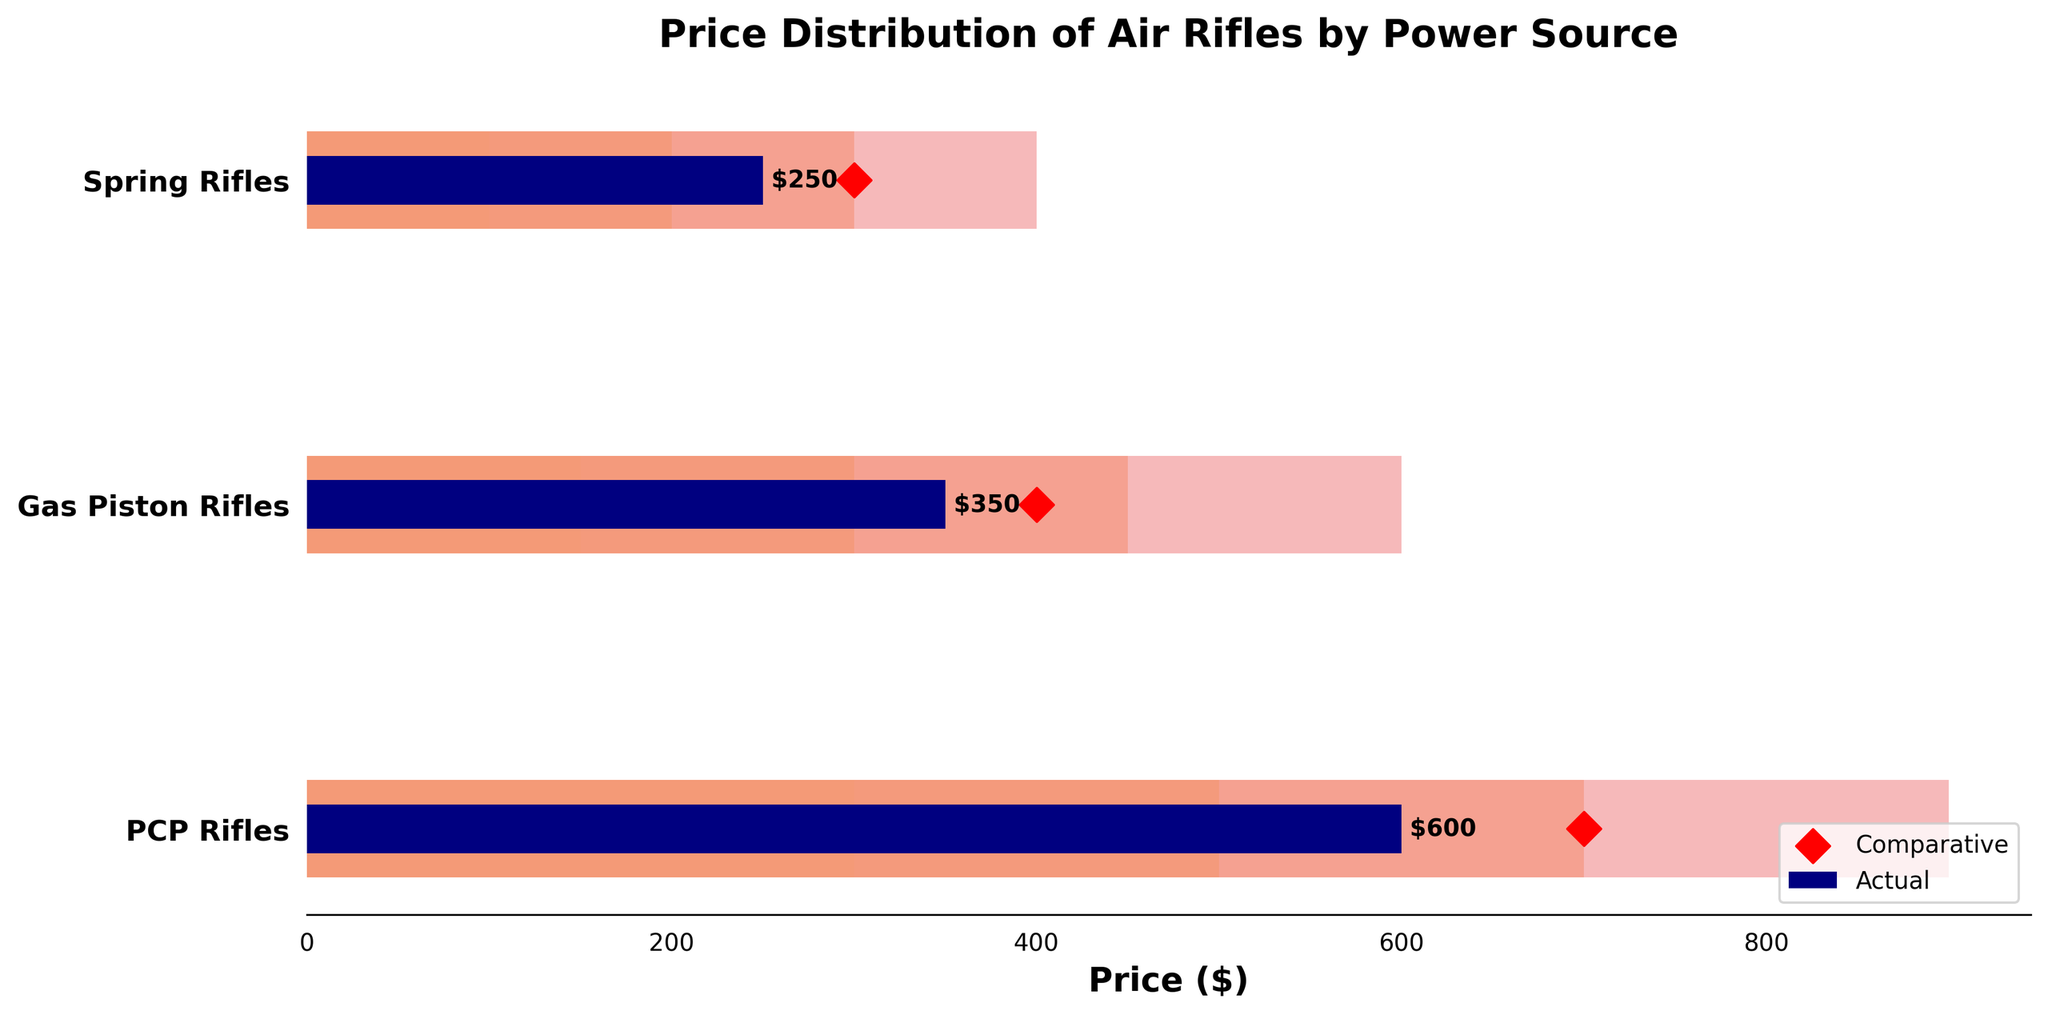What is the title of the chart? The title is located at the top of the figure, typically in larger and bolder text than other elements. It provides a summary of what the chart represents.
Answer: Price Distribution of Air Rifles by Power Source Which power source has the highest actual price? From the chart, you observe the lengths of the navy bars representing actual prices. The PCP Rifles' bar is the longest among the three categories.
Answer: PCP Rifles What is the comparative price for Spring Rifles? Look for the red diamond marker on the horizontal line corresponding to Spring Rifles. The value associated with it is the comparative price.
Answer: 300 How many price ranges are shown in the chart for each category? Each category has 4 shaded regions representing price ranges. This can be counted on the figure directly.
Answer: 4 Which category has its actual price closest to the upper limit of its third range? Compare the actual price bars for each category to their respective third range boundaries. The PCP Rifles' actual price of 600 is equal to its third range upper limit of 700.
Answer: PCP Rifles What is the range of prices for Gas Piston Rifles? Read the four value boundaries from the chart for Gas Piston Rifles, which are 150, 300, 450, and 600. The lowest and highest values give the total range of prices.
Answer: 150-600 Which category's actual price is below the first range boundary? Compare the actual price bars to the first range boundaries for each category. No actual price bars fall below the first range boundary in any category.
Answer: None What is the difference between the comparative prices of PCP Rifles and Gas Piston Rifles? Subtract the comparative price of Gas Piston Rifles from that of PCP Rifles: 700 - 400. This provides the difference in prices.
Answer: 300 Is the actual price of Gas Piston Rifles within its second price range? Compare the actual price of Gas Piston Rifles (350) against its price ranges (150-300-450-600). 350 falls between the second range boundaries of 300 and 450.
Answer: Yes Which power source's actual price is above all its price ranges? Examine the actual price bars and see if any exceed the final range boundary for their category. No actual price exceeds the highest range boundary in any category.
Answer: None 